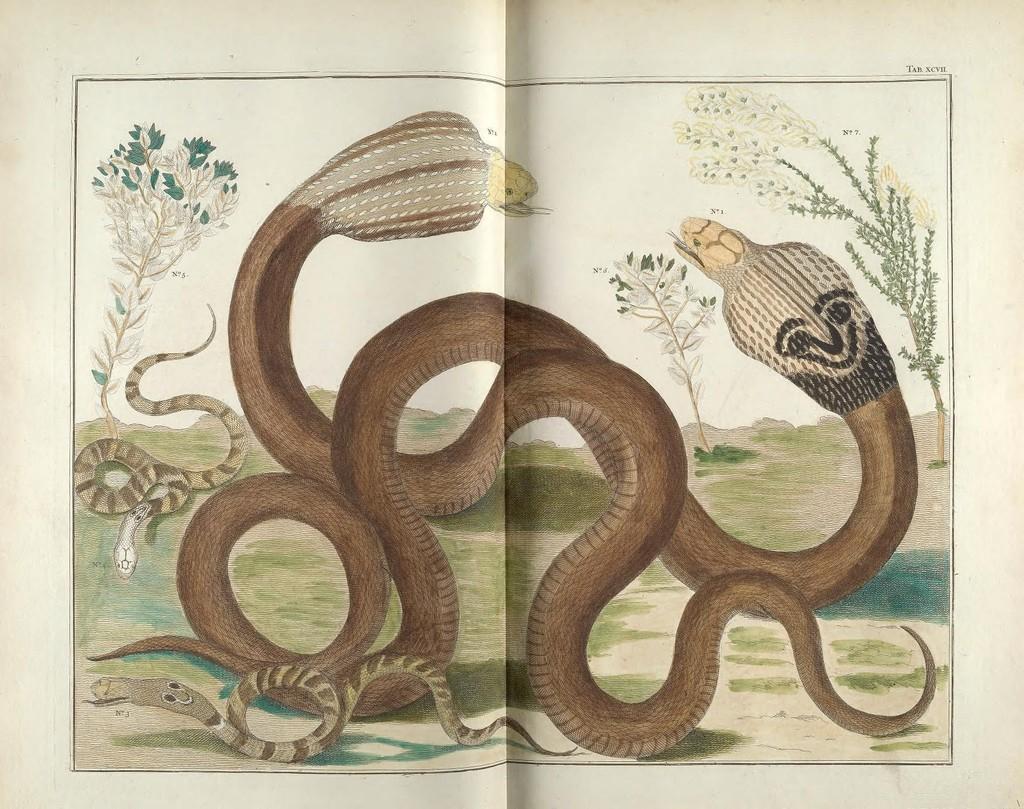Could you give a brief overview of what you see in this image? This is a poster where we can see snakes. At the background we can see few plants. 